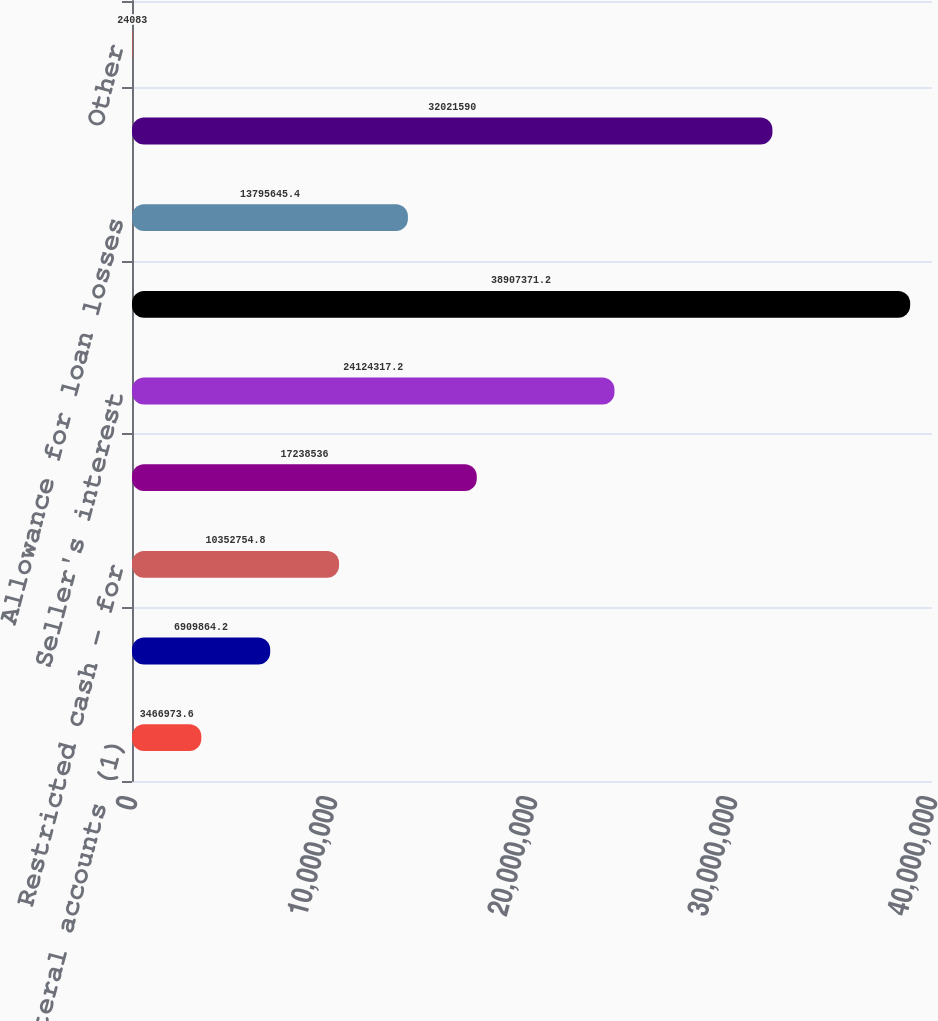<chart> <loc_0><loc_0><loc_500><loc_500><bar_chart><fcel>Cash collateral accounts (1)<fcel>Collections and interest<fcel>Restricted cash - for<fcel>Investors' interests held by<fcel>Seller's interest<fcel>Loan receivables - restricted<fcel>Allowance for loan losses<fcel>Net loan receivables<fcel>Other<nl><fcel>3.46697e+06<fcel>6.90986e+06<fcel>1.03528e+07<fcel>1.72385e+07<fcel>2.41243e+07<fcel>3.89074e+07<fcel>1.37956e+07<fcel>3.20216e+07<fcel>24083<nl></chart> 